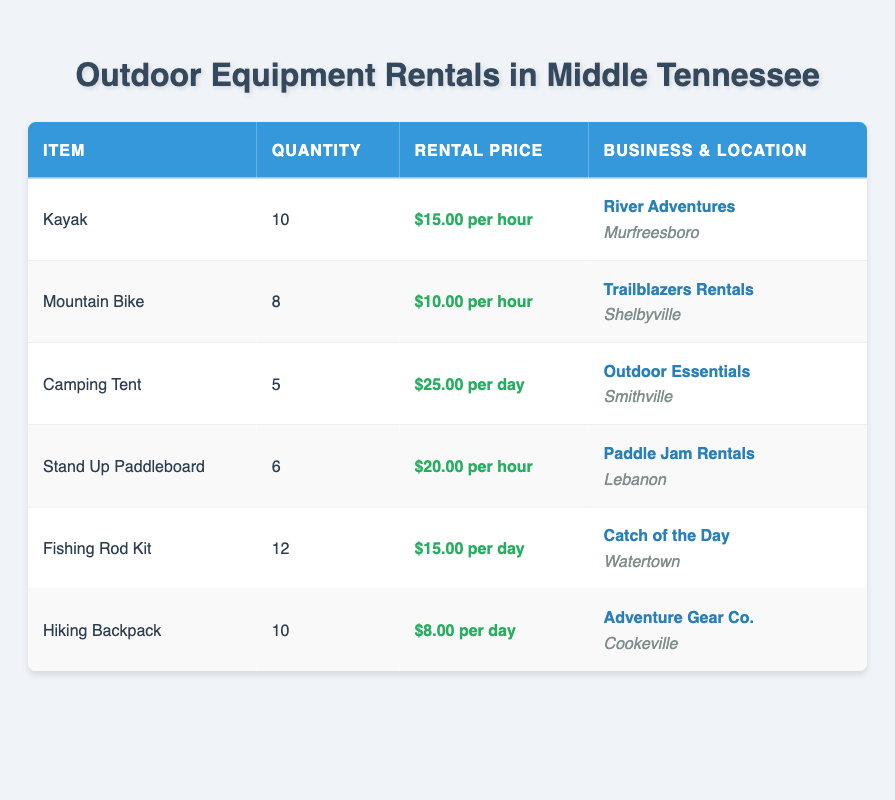What is the rental price per hour for a Kayak? The table shows that the rental price per hour for a Kayak is listed under the "Rental Price" column corresponding to the "Kayak" row, which indicates it is $15.00.
Answer: $15.00 Which business offers Mountain Bikes for rent? Referring to the table, the entry for "Mountain Bike" indicates that "Trailblazers Rentals" is the business providing this equipment, as mentioned in the "Business & Location" column.
Answer: Trailblazers Rentals How many Camping Tents are available for rent? The quantity of available Camping Tents can be found in the "Quantity" column under the "Camping Tent" row, which shows that there are 5 available.
Answer: 5 What is the total rental price per day for renting both a Fishing Rod Kit and a Hiking Backpack? The rental price for a Fishing Rod Kit is $15.00 per day, and for a Hiking Backpack, it is $8.00 per day. Adding these two amounts gives a total of $15.00 + $8.00 = $23.00 per day for renting both items.
Answer: $23.00 Is there any equipment available for rent that has a rental price of $20.00 per hour? Looking at the table, the "Stand Up Paddleboard" has a rental price of $20.00 per hour, which confirms that there is equipment meeting this criteria.
Answer: Yes What equipment has the highest quantity available? The table lists the quantities for each type of equipment, with "Fishing Rod Kit" having the highest quantity at 12 available. No other item exceeds this number.
Answer: Fishing Rod Kit What will be the total cost if I rent a Kayak for 4 hours? The rental price per hour for a Kayak is $15.00. To find the total cost for 4 hours, we multiply the hourly rate by the number of hours: $15.00 * 4 = $60.00. Thus, the total cost will be $60.00.
Answer: $60.00 How many items listed have a rental price per hour? We can examine the rental prices in the table. The items "Kayak," "Mountain Bike," and "Stand Up Paddleboard" charge hourly rental fees. Therefore, there are 3 items with a rental price per hour.
Answer: 3 Is there an outdoor equipment item located in Watertown? Yes, according to the table, the "Fishing Rod Kit" is the equipment available for rent that is located in Watertown, confirming the existence of an outdoor item in that location.
Answer: Yes 